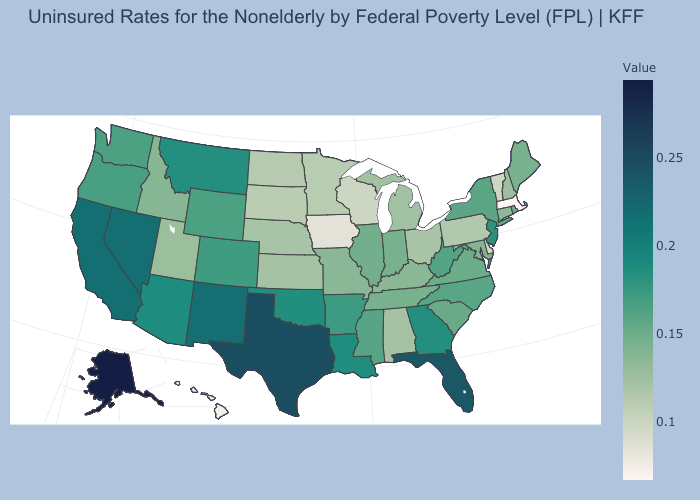Is the legend a continuous bar?
Be succinct. Yes. Among the states that border Pennsylvania , which have the highest value?
Give a very brief answer. New Jersey. Among the states that border Missouri , which have the lowest value?
Give a very brief answer. Iowa. Does Oregon have the lowest value in the USA?
Be succinct. No. Does South Carolina have a higher value than Nevada?
Write a very short answer. No. 